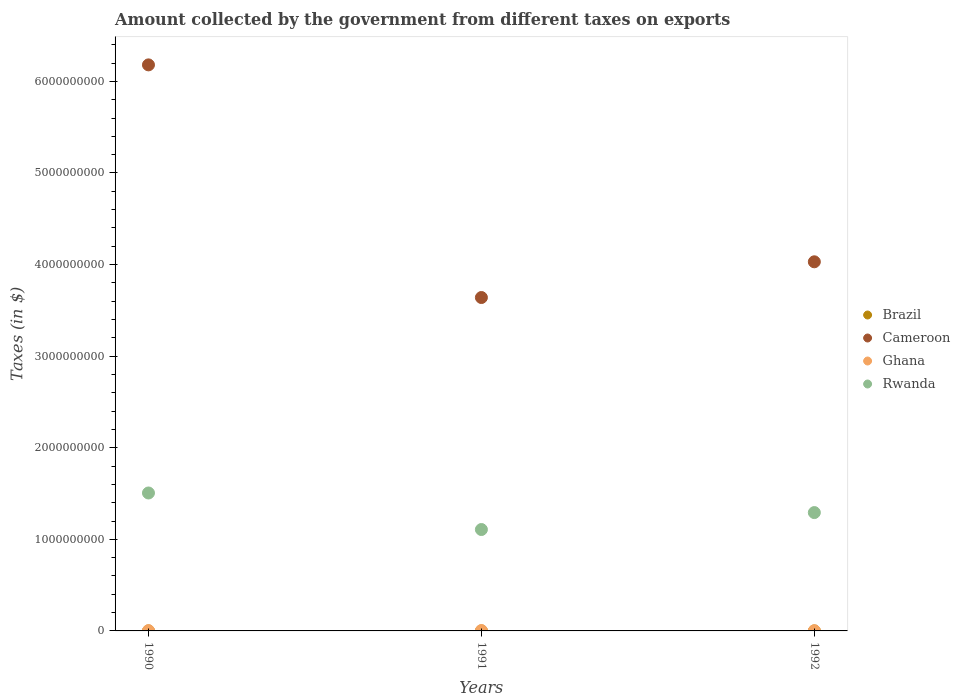Is the number of dotlines equal to the number of legend labels?
Provide a short and direct response. Yes. What is the amount collected by the government from taxes on exports in Cameroon in 1992?
Keep it short and to the point. 4.03e+09. Across all years, what is the maximum amount collected by the government from taxes on exports in Ghana?
Provide a succinct answer. 3.62e+06. Across all years, what is the minimum amount collected by the government from taxes on exports in Rwanda?
Offer a very short reply. 1.11e+09. In which year was the amount collected by the government from taxes on exports in Brazil maximum?
Offer a terse response. 1991. In which year was the amount collected by the government from taxes on exports in Cameroon minimum?
Your response must be concise. 1991. What is the total amount collected by the government from taxes on exports in Brazil in the graph?
Offer a terse response. 3745.45. What is the difference between the amount collected by the government from taxes on exports in Ghana in 1990 and that in 1992?
Provide a succinct answer. 6.82e+05. What is the difference between the amount collected by the government from taxes on exports in Ghana in 1991 and the amount collected by the government from taxes on exports in Cameroon in 1990?
Give a very brief answer. -6.18e+09. What is the average amount collected by the government from taxes on exports in Rwanda per year?
Provide a short and direct response. 1.30e+09. In the year 1992, what is the difference between the amount collected by the government from taxes on exports in Cameroon and amount collected by the government from taxes on exports in Rwanda?
Keep it short and to the point. 2.74e+09. In how many years, is the amount collected by the government from taxes on exports in Brazil greater than 1400000000 $?
Keep it short and to the point. 0. What is the ratio of the amount collected by the government from taxes on exports in Brazil in 1991 to that in 1992?
Your answer should be compact. 1.27. Is the amount collected by the government from taxes on exports in Rwanda in 1991 less than that in 1992?
Ensure brevity in your answer.  Yes. What is the difference between the highest and the second highest amount collected by the government from taxes on exports in Brazil?
Provide a short and direct response. 327.27. What is the difference between the highest and the lowest amount collected by the government from taxes on exports in Ghana?
Keep it short and to the point. 1.58e+06. In how many years, is the amount collected by the government from taxes on exports in Cameroon greater than the average amount collected by the government from taxes on exports in Cameroon taken over all years?
Provide a short and direct response. 1. Is it the case that in every year, the sum of the amount collected by the government from taxes on exports in Brazil and amount collected by the government from taxes on exports in Rwanda  is greater than the amount collected by the government from taxes on exports in Ghana?
Make the answer very short. Yes. Does the amount collected by the government from taxes on exports in Cameroon monotonically increase over the years?
Ensure brevity in your answer.  No. Is the amount collected by the government from taxes on exports in Rwanda strictly greater than the amount collected by the government from taxes on exports in Cameroon over the years?
Give a very brief answer. No. What is the difference between two consecutive major ticks on the Y-axis?
Give a very brief answer. 1.00e+09. Are the values on the major ticks of Y-axis written in scientific E-notation?
Ensure brevity in your answer.  No. Does the graph contain any zero values?
Your answer should be compact. No. Does the graph contain grids?
Ensure brevity in your answer.  No. How are the legend labels stacked?
Ensure brevity in your answer.  Vertical. What is the title of the graph?
Your answer should be very brief. Amount collected by the government from different taxes on exports. What is the label or title of the Y-axis?
Your answer should be compact. Taxes (in $). What is the Taxes (in $) of Brazil in 1990?
Your answer should be very brief. 1018.18. What is the Taxes (in $) of Cameroon in 1990?
Your answer should be very brief. 6.18e+09. What is the Taxes (in $) of Ghana in 1990?
Your response must be concise. 2.72e+06. What is the Taxes (in $) of Rwanda in 1990?
Offer a terse response. 1.51e+09. What is the Taxes (in $) in Brazil in 1991?
Keep it short and to the point. 1527.27. What is the Taxes (in $) of Cameroon in 1991?
Give a very brief answer. 3.64e+09. What is the Taxes (in $) of Ghana in 1991?
Make the answer very short. 3.62e+06. What is the Taxes (in $) in Rwanda in 1991?
Your answer should be very brief. 1.11e+09. What is the Taxes (in $) in Brazil in 1992?
Offer a very short reply. 1200. What is the Taxes (in $) in Cameroon in 1992?
Ensure brevity in your answer.  4.03e+09. What is the Taxes (in $) of Ghana in 1992?
Provide a succinct answer. 2.04e+06. What is the Taxes (in $) of Rwanda in 1992?
Make the answer very short. 1.29e+09. Across all years, what is the maximum Taxes (in $) in Brazil?
Keep it short and to the point. 1527.27. Across all years, what is the maximum Taxes (in $) in Cameroon?
Give a very brief answer. 6.18e+09. Across all years, what is the maximum Taxes (in $) of Ghana?
Offer a very short reply. 3.62e+06. Across all years, what is the maximum Taxes (in $) of Rwanda?
Offer a terse response. 1.51e+09. Across all years, what is the minimum Taxes (in $) in Brazil?
Your answer should be very brief. 1018.18. Across all years, what is the minimum Taxes (in $) of Cameroon?
Offer a very short reply. 3.64e+09. Across all years, what is the minimum Taxes (in $) of Ghana?
Give a very brief answer. 2.04e+06. Across all years, what is the minimum Taxes (in $) in Rwanda?
Offer a very short reply. 1.11e+09. What is the total Taxes (in $) in Brazil in the graph?
Offer a terse response. 3745.45. What is the total Taxes (in $) of Cameroon in the graph?
Your response must be concise. 1.38e+1. What is the total Taxes (in $) of Ghana in the graph?
Make the answer very short. 8.37e+06. What is the total Taxes (in $) of Rwanda in the graph?
Keep it short and to the point. 3.90e+09. What is the difference between the Taxes (in $) in Brazil in 1990 and that in 1991?
Provide a succinct answer. -509.09. What is the difference between the Taxes (in $) of Cameroon in 1990 and that in 1991?
Keep it short and to the point. 2.54e+09. What is the difference between the Taxes (in $) of Ghana in 1990 and that in 1991?
Keep it short and to the point. -8.97e+05. What is the difference between the Taxes (in $) of Rwanda in 1990 and that in 1991?
Your response must be concise. 3.99e+08. What is the difference between the Taxes (in $) of Brazil in 1990 and that in 1992?
Keep it short and to the point. -181.82. What is the difference between the Taxes (in $) of Cameroon in 1990 and that in 1992?
Offer a very short reply. 2.15e+09. What is the difference between the Taxes (in $) of Ghana in 1990 and that in 1992?
Make the answer very short. 6.82e+05. What is the difference between the Taxes (in $) of Rwanda in 1990 and that in 1992?
Offer a very short reply. 2.14e+08. What is the difference between the Taxes (in $) of Brazil in 1991 and that in 1992?
Your response must be concise. 327.27. What is the difference between the Taxes (in $) of Cameroon in 1991 and that in 1992?
Provide a short and direct response. -3.90e+08. What is the difference between the Taxes (in $) in Ghana in 1991 and that in 1992?
Your answer should be compact. 1.58e+06. What is the difference between the Taxes (in $) in Rwanda in 1991 and that in 1992?
Provide a succinct answer. -1.85e+08. What is the difference between the Taxes (in $) of Brazil in 1990 and the Taxes (in $) of Cameroon in 1991?
Provide a succinct answer. -3.64e+09. What is the difference between the Taxes (in $) of Brazil in 1990 and the Taxes (in $) of Ghana in 1991?
Make the answer very short. -3.61e+06. What is the difference between the Taxes (in $) of Brazil in 1990 and the Taxes (in $) of Rwanda in 1991?
Your answer should be compact. -1.11e+09. What is the difference between the Taxes (in $) in Cameroon in 1990 and the Taxes (in $) in Ghana in 1991?
Give a very brief answer. 6.18e+09. What is the difference between the Taxes (in $) in Cameroon in 1990 and the Taxes (in $) in Rwanda in 1991?
Provide a succinct answer. 5.07e+09. What is the difference between the Taxes (in $) of Ghana in 1990 and the Taxes (in $) of Rwanda in 1991?
Your answer should be compact. -1.10e+09. What is the difference between the Taxes (in $) in Brazil in 1990 and the Taxes (in $) in Cameroon in 1992?
Offer a terse response. -4.03e+09. What is the difference between the Taxes (in $) of Brazil in 1990 and the Taxes (in $) of Ghana in 1992?
Offer a very short reply. -2.03e+06. What is the difference between the Taxes (in $) of Brazil in 1990 and the Taxes (in $) of Rwanda in 1992?
Make the answer very short. -1.29e+09. What is the difference between the Taxes (in $) in Cameroon in 1990 and the Taxes (in $) in Ghana in 1992?
Offer a very short reply. 6.18e+09. What is the difference between the Taxes (in $) of Cameroon in 1990 and the Taxes (in $) of Rwanda in 1992?
Keep it short and to the point. 4.89e+09. What is the difference between the Taxes (in $) in Ghana in 1990 and the Taxes (in $) in Rwanda in 1992?
Offer a terse response. -1.29e+09. What is the difference between the Taxes (in $) of Brazil in 1991 and the Taxes (in $) of Cameroon in 1992?
Your response must be concise. -4.03e+09. What is the difference between the Taxes (in $) of Brazil in 1991 and the Taxes (in $) of Ghana in 1992?
Offer a terse response. -2.03e+06. What is the difference between the Taxes (in $) in Brazil in 1991 and the Taxes (in $) in Rwanda in 1992?
Provide a short and direct response. -1.29e+09. What is the difference between the Taxes (in $) of Cameroon in 1991 and the Taxes (in $) of Ghana in 1992?
Make the answer very short. 3.64e+09. What is the difference between the Taxes (in $) of Cameroon in 1991 and the Taxes (in $) of Rwanda in 1992?
Make the answer very short. 2.35e+09. What is the difference between the Taxes (in $) in Ghana in 1991 and the Taxes (in $) in Rwanda in 1992?
Ensure brevity in your answer.  -1.29e+09. What is the average Taxes (in $) in Brazil per year?
Keep it short and to the point. 1248.48. What is the average Taxes (in $) of Cameroon per year?
Offer a terse response. 4.62e+09. What is the average Taxes (in $) of Ghana per year?
Ensure brevity in your answer.  2.79e+06. What is the average Taxes (in $) of Rwanda per year?
Offer a terse response. 1.30e+09. In the year 1990, what is the difference between the Taxes (in $) of Brazil and Taxes (in $) of Cameroon?
Your response must be concise. -6.18e+09. In the year 1990, what is the difference between the Taxes (in $) in Brazil and Taxes (in $) in Ghana?
Keep it short and to the point. -2.72e+06. In the year 1990, what is the difference between the Taxes (in $) of Brazil and Taxes (in $) of Rwanda?
Your response must be concise. -1.51e+09. In the year 1990, what is the difference between the Taxes (in $) in Cameroon and Taxes (in $) in Ghana?
Your answer should be very brief. 6.18e+09. In the year 1990, what is the difference between the Taxes (in $) in Cameroon and Taxes (in $) in Rwanda?
Offer a terse response. 4.67e+09. In the year 1990, what is the difference between the Taxes (in $) in Ghana and Taxes (in $) in Rwanda?
Provide a short and direct response. -1.50e+09. In the year 1991, what is the difference between the Taxes (in $) of Brazil and Taxes (in $) of Cameroon?
Keep it short and to the point. -3.64e+09. In the year 1991, what is the difference between the Taxes (in $) of Brazil and Taxes (in $) of Ghana?
Provide a short and direct response. -3.61e+06. In the year 1991, what is the difference between the Taxes (in $) in Brazil and Taxes (in $) in Rwanda?
Ensure brevity in your answer.  -1.11e+09. In the year 1991, what is the difference between the Taxes (in $) of Cameroon and Taxes (in $) of Ghana?
Make the answer very short. 3.64e+09. In the year 1991, what is the difference between the Taxes (in $) in Cameroon and Taxes (in $) in Rwanda?
Ensure brevity in your answer.  2.53e+09. In the year 1991, what is the difference between the Taxes (in $) in Ghana and Taxes (in $) in Rwanda?
Ensure brevity in your answer.  -1.10e+09. In the year 1992, what is the difference between the Taxes (in $) of Brazil and Taxes (in $) of Cameroon?
Offer a very short reply. -4.03e+09. In the year 1992, what is the difference between the Taxes (in $) in Brazil and Taxes (in $) in Ghana?
Your response must be concise. -2.03e+06. In the year 1992, what is the difference between the Taxes (in $) in Brazil and Taxes (in $) in Rwanda?
Your response must be concise. -1.29e+09. In the year 1992, what is the difference between the Taxes (in $) of Cameroon and Taxes (in $) of Ghana?
Keep it short and to the point. 4.03e+09. In the year 1992, what is the difference between the Taxes (in $) of Cameroon and Taxes (in $) of Rwanda?
Provide a short and direct response. 2.74e+09. In the year 1992, what is the difference between the Taxes (in $) of Ghana and Taxes (in $) of Rwanda?
Offer a terse response. -1.29e+09. What is the ratio of the Taxes (in $) in Cameroon in 1990 to that in 1991?
Give a very brief answer. 1.7. What is the ratio of the Taxes (in $) in Ghana in 1990 to that in 1991?
Keep it short and to the point. 0.75. What is the ratio of the Taxes (in $) in Rwanda in 1990 to that in 1991?
Give a very brief answer. 1.36. What is the ratio of the Taxes (in $) of Brazil in 1990 to that in 1992?
Provide a succinct answer. 0.85. What is the ratio of the Taxes (in $) in Cameroon in 1990 to that in 1992?
Offer a terse response. 1.53. What is the ratio of the Taxes (in $) in Ghana in 1990 to that in 1992?
Make the answer very short. 1.34. What is the ratio of the Taxes (in $) of Rwanda in 1990 to that in 1992?
Offer a terse response. 1.17. What is the ratio of the Taxes (in $) in Brazil in 1991 to that in 1992?
Your answer should be very brief. 1.27. What is the ratio of the Taxes (in $) in Cameroon in 1991 to that in 1992?
Your answer should be very brief. 0.9. What is the ratio of the Taxes (in $) of Ghana in 1991 to that in 1992?
Your answer should be compact. 1.78. What is the ratio of the Taxes (in $) in Rwanda in 1991 to that in 1992?
Your answer should be very brief. 0.86. What is the difference between the highest and the second highest Taxes (in $) of Brazil?
Your answer should be very brief. 327.27. What is the difference between the highest and the second highest Taxes (in $) of Cameroon?
Your answer should be compact. 2.15e+09. What is the difference between the highest and the second highest Taxes (in $) in Ghana?
Give a very brief answer. 8.97e+05. What is the difference between the highest and the second highest Taxes (in $) in Rwanda?
Make the answer very short. 2.14e+08. What is the difference between the highest and the lowest Taxes (in $) of Brazil?
Give a very brief answer. 509.09. What is the difference between the highest and the lowest Taxes (in $) of Cameroon?
Your answer should be very brief. 2.54e+09. What is the difference between the highest and the lowest Taxes (in $) in Ghana?
Make the answer very short. 1.58e+06. What is the difference between the highest and the lowest Taxes (in $) in Rwanda?
Give a very brief answer. 3.99e+08. 